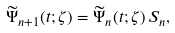<formula> <loc_0><loc_0><loc_500><loc_500>\widetilde { \Psi } _ { n + 1 } ( t ; \zeta ) = \widetilde { \Psi } _ { n } ( t ; \zeta ) \, S _ { n } ,</formula> 